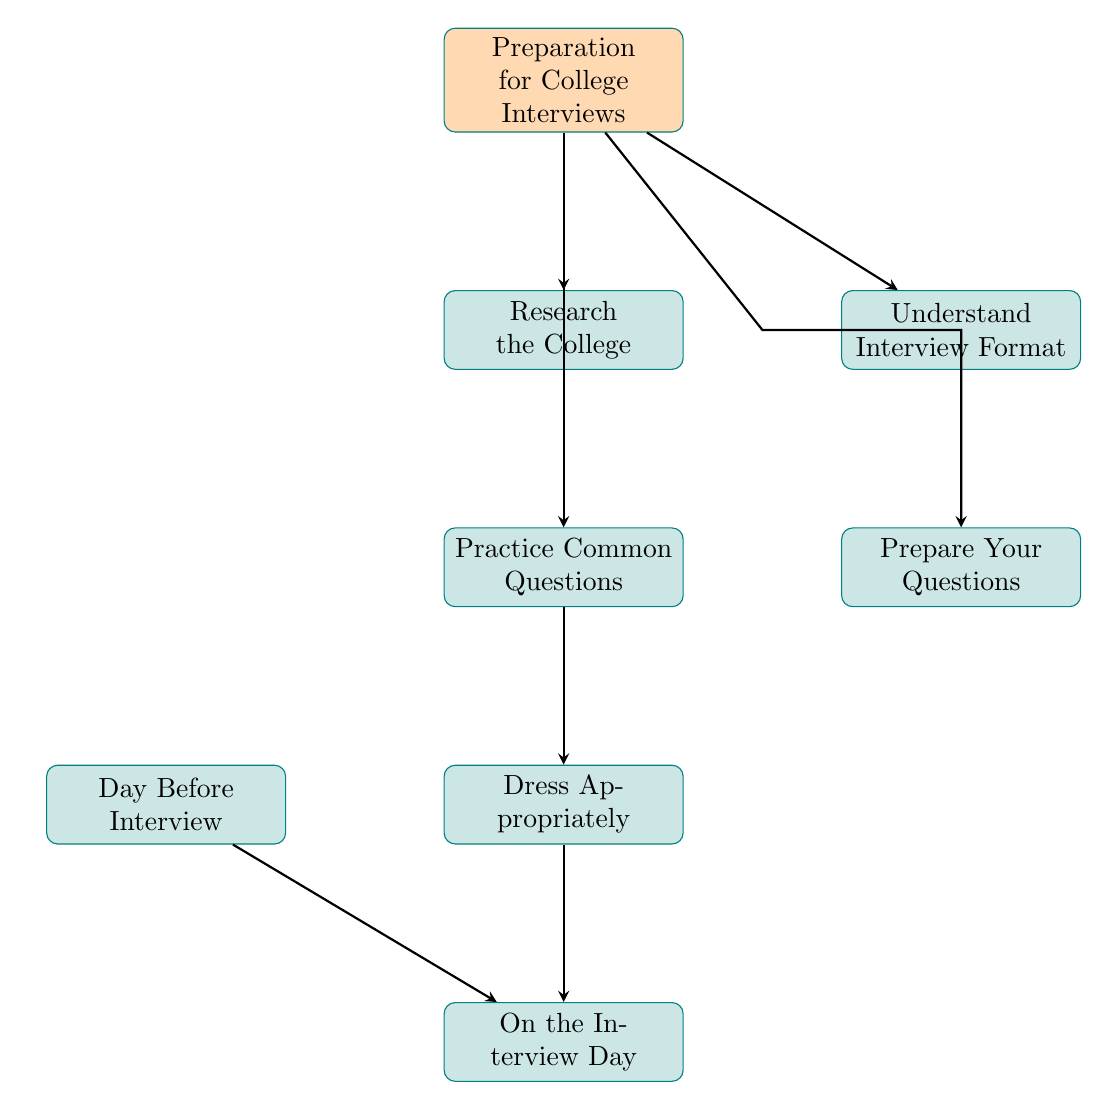What is the first step in preparing for college interviews? The first node in the diagram is "Preparation for College Interviews," which branches to different aspects of preparation. The first step that is explicitly mentioned following the main node is "Research the College."
Answer: Research the College How many main preparation categories are listed in the diagram? The diagram has six main preparation categories connected to the starting node: "Research the College," "Understand Interview Format," "Practice Common Questions," "Prepare Your Questions," "Dress Appropriately," and "Day Before Interview." Counting these gives a total of six.
Answer: Six What follows after "Practice Common Questions"? From the diagram, "Practice Common Questions" leads directly to the node "Dress Appropriately." This indicates that dressing appropriately is the next step after practicing common questions.
Answer: Dress Appropriately What are the two topics under "Understand Interview Format"? The "Understand Interview Format" node has two specific sub-nodes: "Interview Type" and "Interview Medium." These topics explain the different aspects of interview formats.
Answer: Interview Type and Interview Medium If "Day Before Interview" is not completed, what will happen next? The "Day Before Interview" node connects to "On the Interview Day," meaning that if preparations from the "Day Before Interview" aren't completed, you will still arrive at the "On the Interview Day" step. However, proper preparation could be crucial for success.
Answer: On the Interview Day What does the "Dress Appropriately" node emphasize? The "Dress Appropriately" node has two key points: "Professional Attire" and "Comfort." Both aspects highlight the importance of being professionally dressed while ensuring comfort on interview day.
Answer: Professional Attire and Comfort 